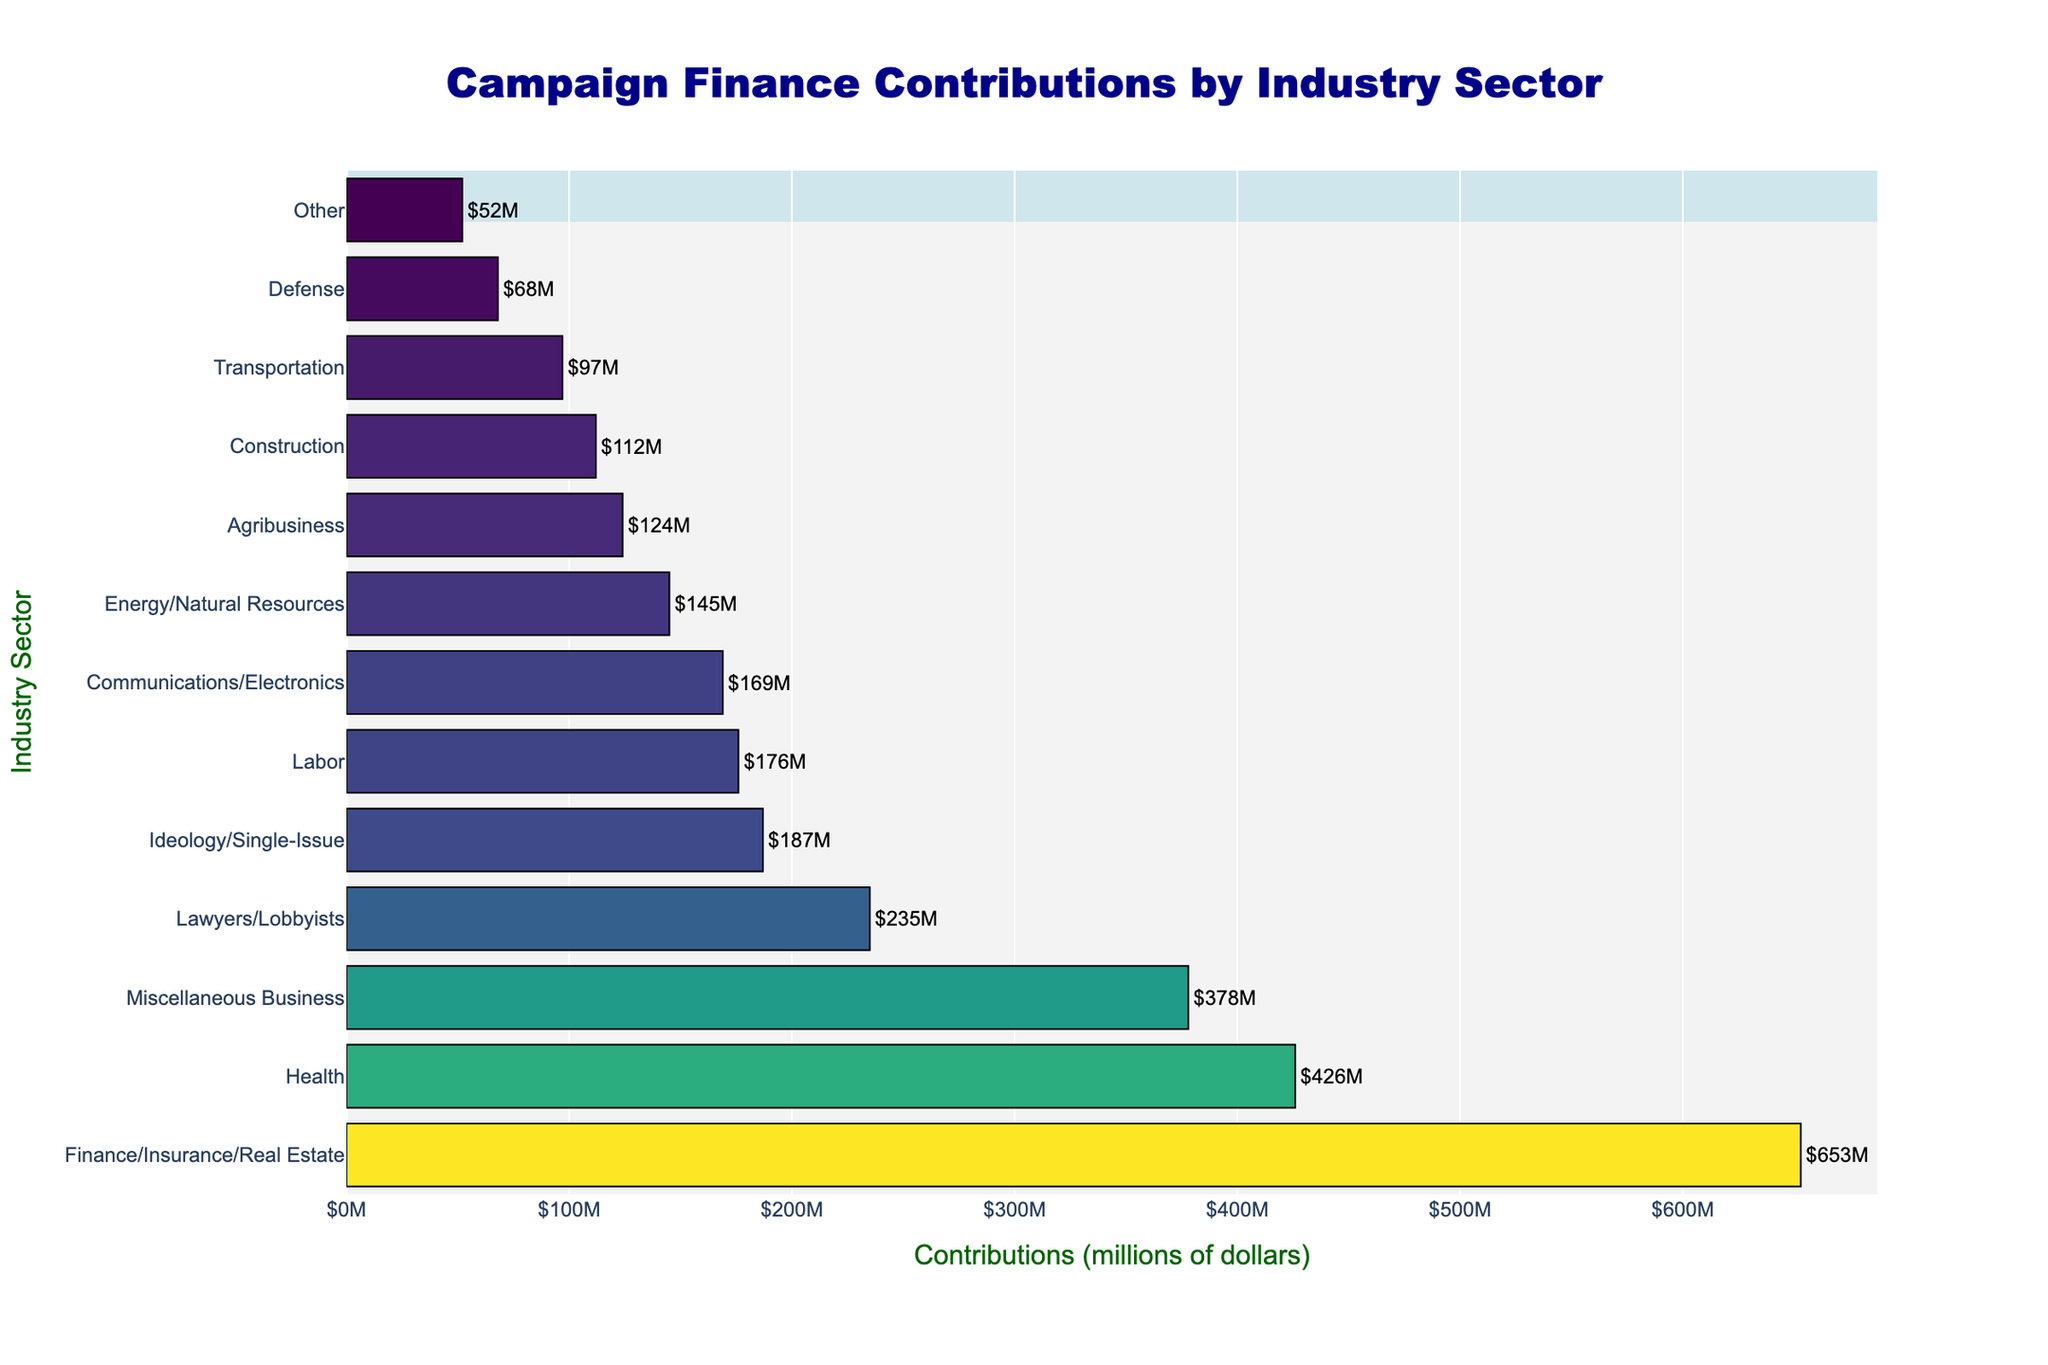What's the total amount of contributions from the top three industry sectors? To find the total contributions from the top three industry sectors, identify the corresponding values: Finance/Insurance/Real Estate ($653M), Health ($426M), and Miscellaneous Business ($378M). Summing these values: $653M + $426M + $378M = $1,457M
Answer: $1,457M Which two industry sectors have the smallest contributions, and what are their corresponding values? Identify the two industry sectors with the smallest values from the figure, which are "Other" ($52M) and "Defense" ($68M).
Answer: Other: $52M, Defense: $68M By how much do contributions from Lawyers/Lobbyists exceed those from Communications/Electronics? To determine the difference, locate the contributions for each group: Lawyers/Lobbyists ($235M) and Communications/Electronics ($169M). Calculate the difference: $235M - $169M = $66M
Answer: $66M What is the average contribution amount of all listed industry sectors? Sum up all the contributions: $653M + $426M + $378M + $235M + $187M + $176M + $169M + $145M + $124M + $112M + $97M + $68M + $52M = $2,822M. There are 13 industry sectors. The average is $2,822M / 13 ≈ $217M
Answer: $217M Which industry sector has contributions closest to the median value, and what is that value? First, list all the contributions in ascending order: $52M, $68M, $97M, $112M, $124M, $145M, $169M, $176M, $187M, $235M, $378M, $426M, $653M. The median is the middle value (7th), which is $169M, belonging to Communications/Electronics.
Answer: Communications/Electronics: $169M How do contributions from the Finance/Insurance/Real Estate sector compare to the combined contributions of the Energy/Natural Resources and Agribusiness sectors? Find the contributions: Finance/Insurance/Real Estate ($653M), Energy/Natural Resources ($145M), and Agribusiness ($124M). Combine the latter two: $145M + $124M = $269M. Compare $653M to $269M: $653M is significantly greater.
Answer: Finance/Insurance/Real Estate is greater by $384M What visual feature helps to easily identify the highest contribution amount, and which industry does it belong to? The highest contribution is visually indicated by the longest bar in the plot. It corresponds to the Finance/Insurance/Real Estate sector.
Answer: The longest bar, Finance/Insurance/Real Estate Between the Health and Labor sectors, which sector contributes less and by how much? Locate the contributions: Health ($426M) and Labor ($176M). Subtract to find the difference: $426M - $176M = $250M
Answer: Labor contributes $250M less 